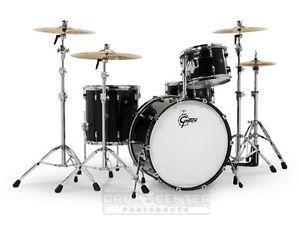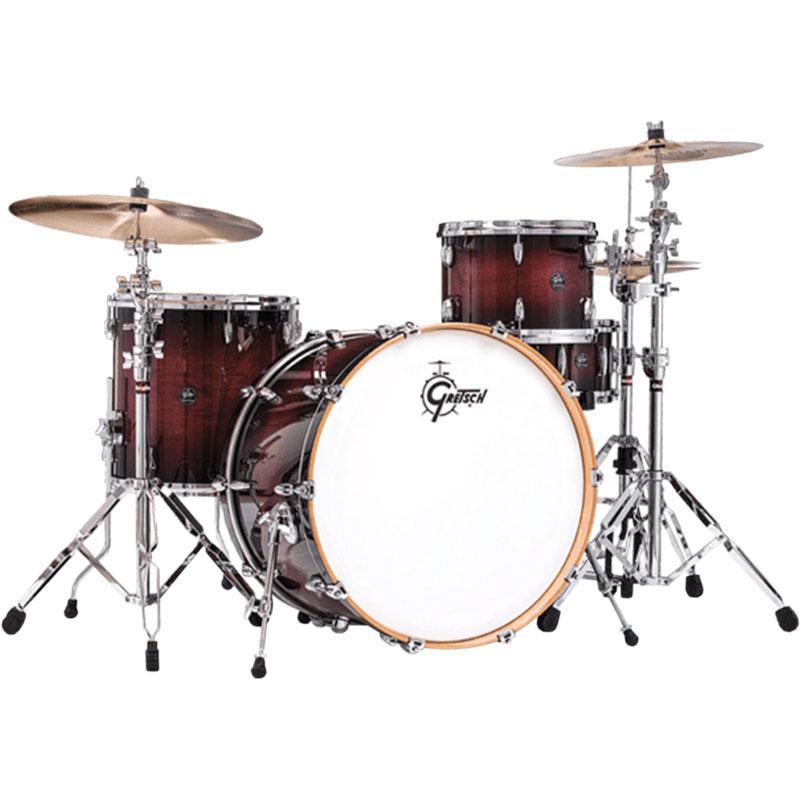The first image is the image on the left, the second image is the image on the right. Evaluate the accuracy of this statement regarding the images: "A drum set is placed on a white carpet in front of a black background in one of the pictures.". Is it true? Answer yes or no. No. The first image is the image on the left, the second image is the image on the right. Given the left and right images, does the statement "One set of drums has black sides and is flanked by two cymbals per side, and the other set of drums has wood-grain sides and is flanked by one cymbal per side." hold true? Answer yes or no. Yes. 